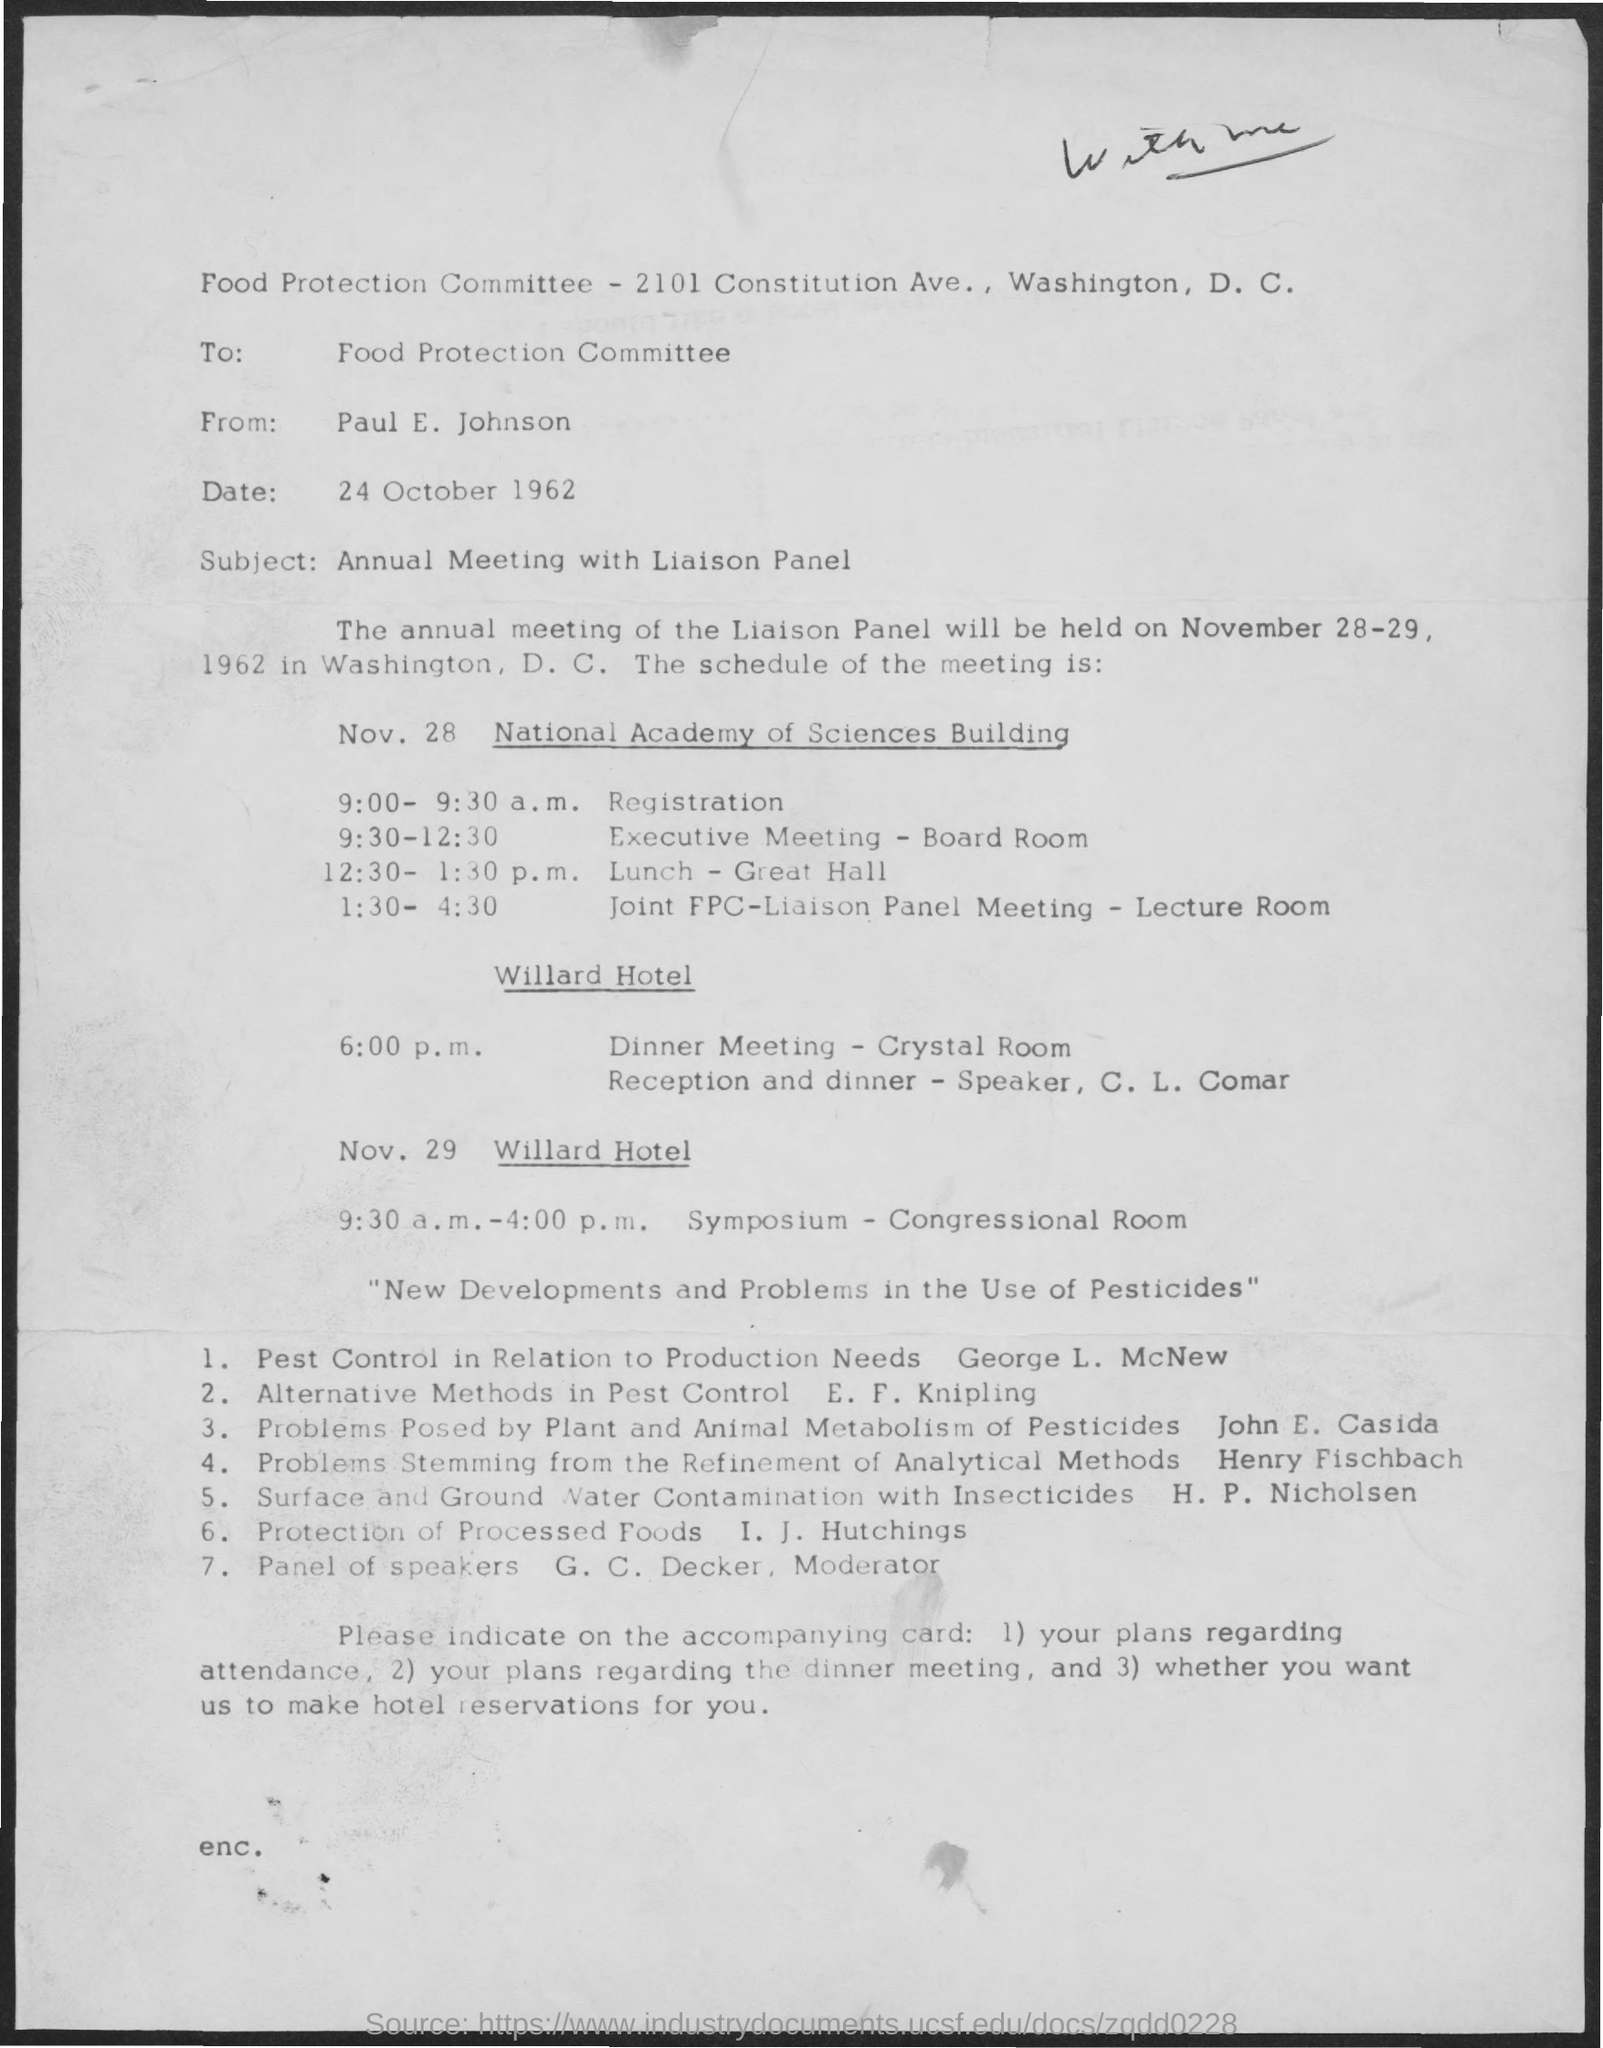What is the address for Food Protection committee?
Offer a very short reply. 2101 Constitution Ave., Washington, D. C. To Whom is this letter addressed to?
Make the answer very short. Food Protection Committee. Who is this letter from?
Your answer should be very brief. Paul E. Johnson. What is the Date?
Your answer should be compact. 24 October 1962. What is the subject?
Keep it short and to the point. Annual Meeting with Liaison Panel. When will the annual meeting of Liaison Panel be held?
Make the answer very short. November 28-29, 1962. Where will the annual meeting of Liaison Panel be held?
Make the answer very short. Washington, D. C. What Time will the Nov. 29 Symposium be held?
Make the answer very short. 9:30 a.m. - 4:00 p.m. What time is the registration?
Give a very brief answer. 9:00 - 9:30 a.m. 